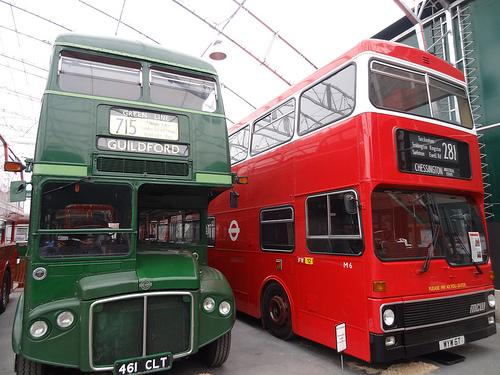Identify the two main colors of the buses in the image. Green and red. Determine the license plate color on the green bus. The license plate on the green bus is black and white. What text can be found on the front of the bus in the image? The text "Guildford" can be found on the front of the bus. Count the number of windows on the buses mentioned in the image. There are ten windows mentioned for the buses in the image. What are the objects mentioned in the image interacting with the buses? Headlights, license plates, signs, wind shield wipers, and side lights interact with the buses in the image. How many headlights can be seen on the image? Six headlights are visible on the image. Analyze the sentiment or emotions elicited by the image. The image evokes a nostalgic and cheerful sentiment, as it features vintage double decker buses with bright colors and intricate details. Estimate the objective quality of the image, considering the details provided. The image seems to be of high quality, with a multitude of precise details including object sizes, positions, and descriptions for various elements. Write a brief description of the vintage double decker buses in the image. Two vintage double decker buses are present, one green and one red, with numerous windows, windshield wipers, headlights, and license plates. Observe the two bicycles leaning against the back of the red bus. A couple of bicycles are resting against the rear portion of the red bus, perhaps belonging to passengers who will board later. Can you identify the open luggage compartment on the side of the green bus? There's a compartment on the side of the green bus that has been left open, revealing suitcases inside. Do you see the flock of birds perched on the green bus roof? The green bus is acting as a resting place for a dozen birds that appear to be taking a break from flying. Locate the person sitting inside the upper front window of the red bus. A man with sunglasses and a hat is seated in the front row of the upper level of the red bus, enjoying the view. Please take note of the flying saucer hovering above the buses. An alien spaceship can be seen floating above the buses, and it seems to be observing them. Can you spot the unicorn standing next to the buses? There's a unicorn with a rainbow-colored horn standing beside the red bus. 